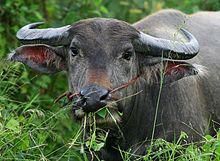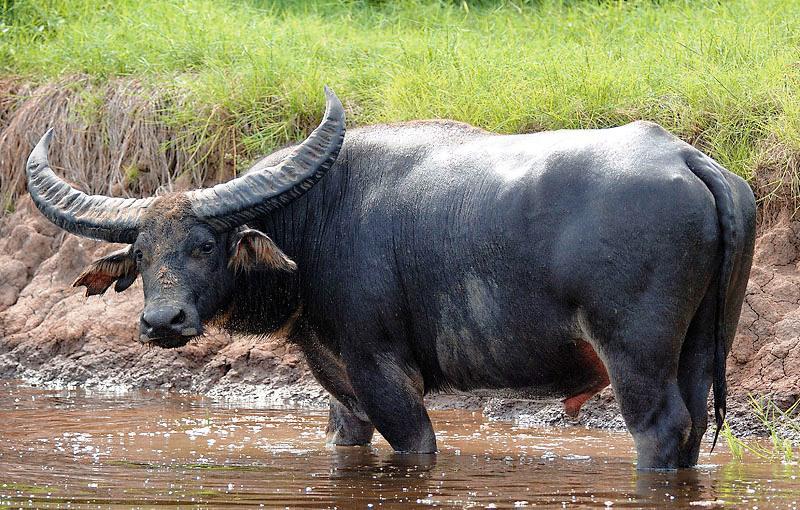The first image is the image on the left, the second image is the image on the right. Given the left and right images, does the statement "A water buffalo is standing in water." hold true? Answer yes or no. Yes. The first image is the image on the left, the second image is the image on the right. Evaluate the accuracy of this statement regarding the images: "An image shows a water buffalo standing in water.". Is it true? Answer yes or no. Yes. 